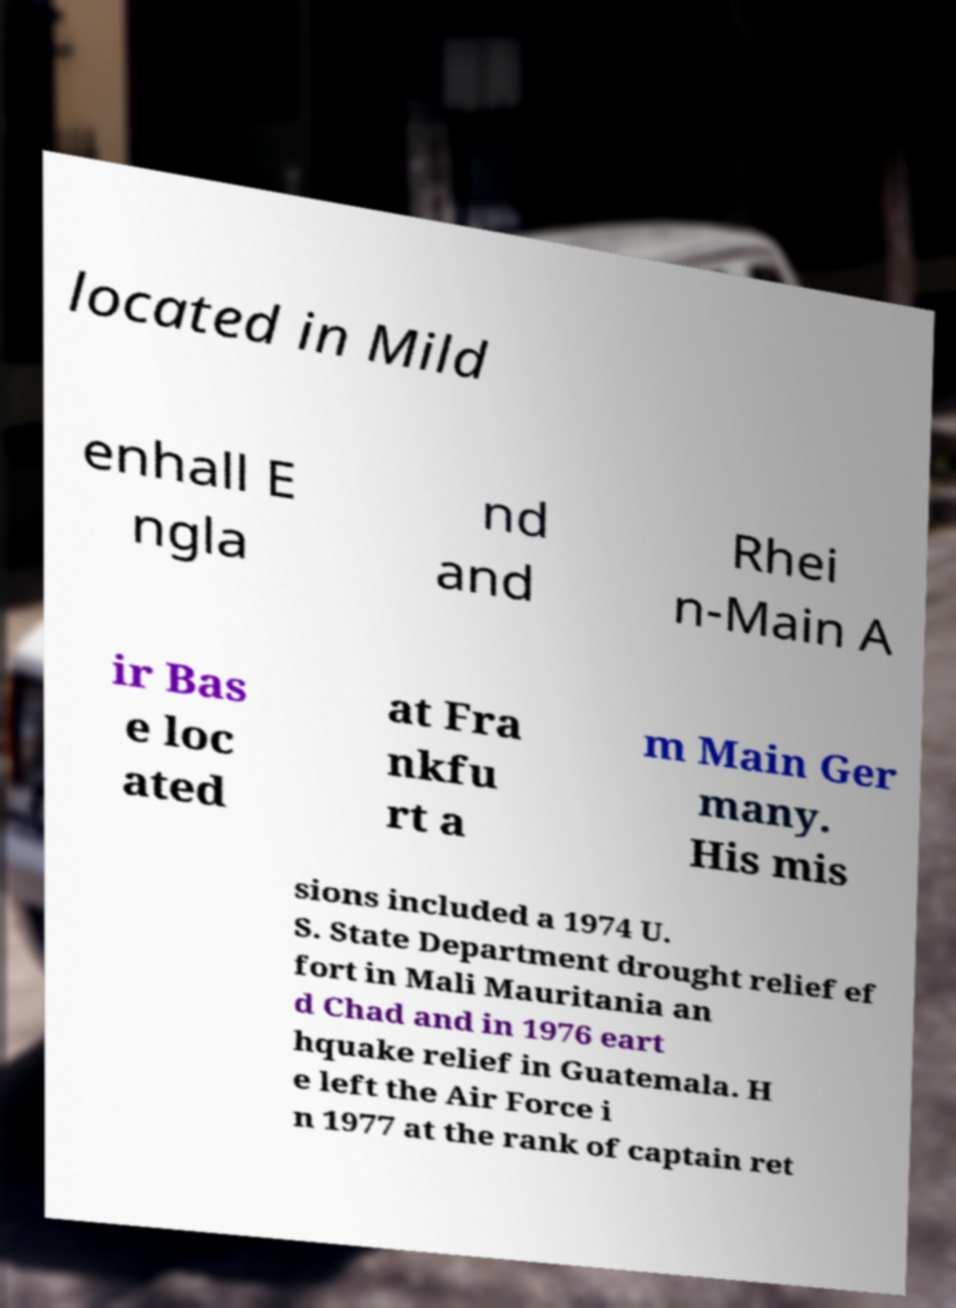Can you accurately transcribe the text from the provided image for me? located in Mild enhall E ngla nd and Rhei n-Main A ir Bas e loc ated at Fra nkfu rt a m Main Ger many. His mis sions included a 1974 U. S. State Department drought relief ef fort in Mali Mauritania an d Chad and in 1976 eart hquake relief in Guatemala. H e left the Air Force i n 1977 at the rank of captain ret 